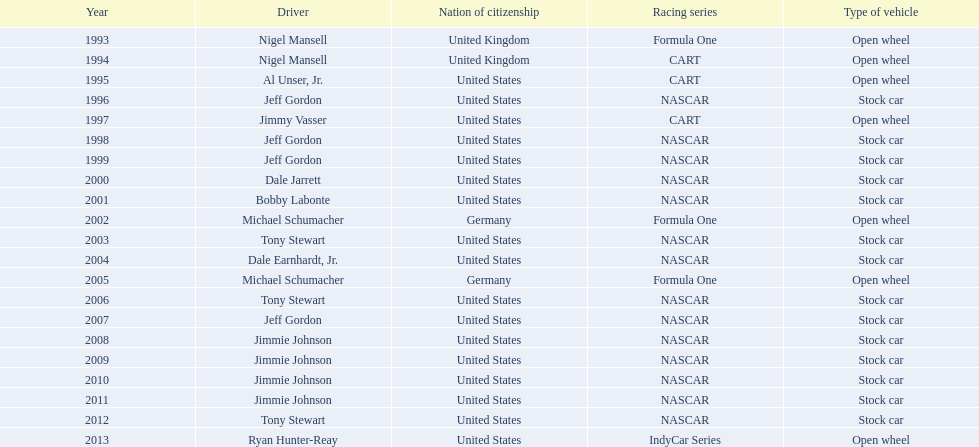Which racing series has the highest total of winners? NASCAR. 